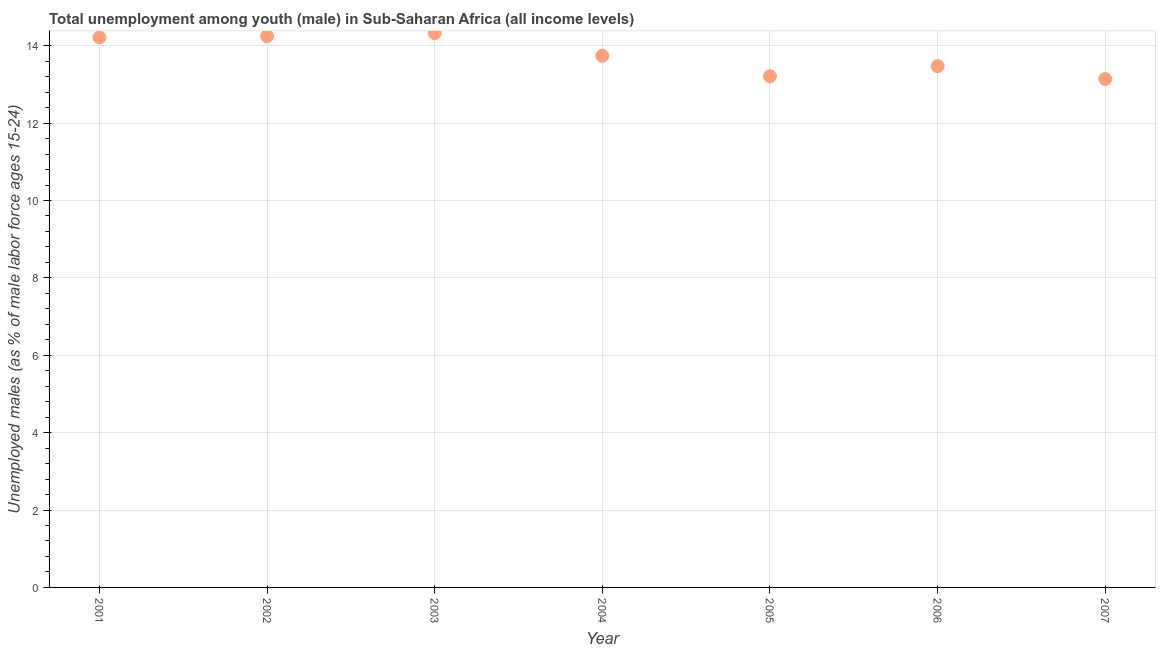What is the unemployed male youth population in 2003?
Your answer should be compact. 14.33. Across all years, what is the maximum unemployed male youth population?
Ensure brevity in your answer.  14.33. Across all years, what is the minimum unemployed male youth population?
Make the answer very short. 13.14. In which year was the unemployed male youth population maximum?
Offer a very short reply. 2003. What is the sum of the unemployed male youth population?
Make the answer very short. 96.35. What is the difference between the unemployed male youth population in 2003 and 2004?
Give a very brief answer. 0.59. What is the average unemployed male youth population per year?
Your answer should be compact. 13.76. What is the median unemployed male youth population?
Your answer should be very brief. 13.74. Do a majority of the years between 2005 and 2004 (inclusive) have unemployed male youth population greater than 1.2000000000000002 %?
Offer a terse response. No. What is the ratio of the unemployed male youth population in 2001 to that in 2007?
Your answer should be compact. 1.08. Is the unemployed male youth population in 2003 less than that in 2004?
Ensure brevity in your answer.  No. What is the difference between the highest and the second highest unemployed male youth population?
Offer a terse response. 0.08. What is the difference between the highest and the lowest unemployed male youth population?
Your response must be concise. 1.19. How many years are there in the graph?
Keep it short and to the point. 7. What is the difference between two consecutive major ticks on the Y-axis?
Your answer should be very brief. 2. Does the graph contain any zero values?
Make the answer very short. No. What is the title of the graph?
Give a very brief answer. Total unemployment among youth (male) in Sub-Saharan Africa (all income levels). What is the label or title of the Y-axis?
Your response must be concise. Unemployed males (as % of male labor force ages 15-24). What is the Unemployed males (as % of male labor force ages 15-24) in 2001?
Ensure brevity in your answer.  14.22. What is the Unemployed males (as % of male labor force ages 15-24) in 2002?
Offer a terse response. 14.25. What is the Unemployed males (as % of male labor force ages 15-24) in 2003?
Keep it short and to the point. 14.33. What is the Unemployed males (as % of male labor force ages 15-24) in 2004?
Your answer should be very brief. 13.74. What is the Unemployed males (as % of male labor force ages 15-24) in 2005?
Your answer should be very brief. 13.21. What is the Unemployed males (as % of male labor force ages 15-24) in 2006?
Provide a succinct answer. 13.47. What is the Unemployed males (as % of male labor force ages 15-24) in 2007?
Your answer should be very brief. 13.14. What is the difference between the Unemployed males (as % of male labor force ages 15-24) in 2001 and 2002?
Give a very brief answer. -0.03. What is the difference between the Unemployed males (as % of male labor force ages 15-24) in 2001 and 2003?
Your answer should be very brief. -0.11. What is the difference between the Unemployed males (as % of male labor force ages 15-24) in 2001 and 2004?
Your answer should be compact. 0.48. What is the difference between the Unemployed males (as % of male labor force ages 15-24) in 2001 and 2005?
Give a very brief answer. 1.01. What is the difference between the Unemployed males (as % of male labor force ages 15-24) in 2001 and 2006?
Provide a succinct answer. 0.74. What is the difference between the Unemployed males (as % of male labor force ages 15-24) in 2001 and 2007?
Your response must be concise. 1.08. What is the difference between the Unemployed males (as % of male labor force ages 15-24) in 2002 and 2003?
Your answer should be very brief. -0.08. What is the difference between the Unemployed males (as % of male labor force ages 15-24) in 2002 and 2004?
Your answer should be compact. 0.5. What is the difference between the Unemployed males (as % of male labor force ages 15-24) in 2002 and 2005?
Offer a terse response. 1.04. What is the difference between the Unemployed males (as % of male labor force ages 15-24) in 2002 and 2006?
Keep it short and to the point. 0.77. What is the difference between the Unemployed males (as % of male labor force ages 15-24) in 2002 and 2007?
Your answer should be compact. 1.11. What is the difference between the Unemployed males (as % of male labor force ages 15-24) in 2003 and 2004?
Your answer should be compact. 0.59. What is the difference between the Unemployed males (as % of male labor force ages 15-24) in 2003 and 2005?
Ensure brevity in your answer.  1.12. What is the difference between the Unemployed males (as % of male labor force ages 15-24) in 2003 and 2006?
Your response must be concise. 0.85. What is the difference between the Unemployed males (as % of male labor force ages 15-24) in 2003 and 2007?
Offer a terse response. 1.19. What is the difference between the Unemployed males (as % of male labor force ages 15-24) in 2004 and 2005?
Your answer should be compact. 0.53. What is the difference between the Unemployed males (as % of male labor force ages 15-24) in 2004 and 2006?
Give a very brief answer. 0.27. What is the difference between the Unemployed males (as % of male labor force ages 15-24) in 2004 and 2007?
Provide a short and direct response. 0.6. What is the difference between the Unemployed males (as % of male labor force ages 15-24) in 2005 and 2006?
Keep it short and to the point. -0.26. What is the difference between the Unemployed males (as % of male labor force ages 15-24) in 2005 and 2007?
Keep it short and to the point. 0.07. What is the difference between the Unemployed males (as % of male labor force ages 15-24) in 2006 and 2007?
Provide a succinct answer. 0.33. What is the ratio of the Unemployed males (as % of male labor force ages 15-24) in 2001 to that in 2002?
Give a very brief answer. 1. What is the ratio of the Unemployed males (as % of male labor force ages 15-24) in 2001 to that in 2004?
Provide a succinct answer. 1.03. What is the ratio of the Unemployed males (as % of male labor force ages 15-24) in 2001 to that in 2005?
Provide a succinct answer. 1.08. What is the ratio of the Unemployed males (as % of male labor force ages 15-24) in 2001 to that in 2006?
Offer a terse response. 1.05. What is the ratio of the Unemployed males (as % of male labor force ages 15-24) in 2001 to that in 2007?
Give a very brief answer. 1.08. What is the ratio of the Unemployed males (as % of male labor force ages 15-24) in 2002 to that in 2005?
Provide a short and direct response. 1.08. What is the ratio of the Unemployed males (as % of male labor force ages 15-24) in 2002 to that in 2006?
Offer a very short reply. 1.06. What is the ratio of the Unemployed males (as % of male labor force ages 15-24) in 2002 to that in 2007?
Offer a terse response. 1.08. What is the ratio of the Unemployed males (as % of male labor force ages 15-24) in 2003 to that in 2004?
Ensure brevity in your answer.  1.04. What is the ratio of the Unemployed males (as % of male labor force ages 15-24) in 2003 to that in 2005?
Offer a terse response. 1.08. What is the ratio of the Unemployed males (as % of male labor force ages 15-24) in 2003 to that in 2006?
Your response must be concise. 1.06. What is the ratio of the Unemployed males (as % of male labor force ages 15-24) in 2003 to that in 2007?
Make the answer very short. 1.09. What is the ratio of the Unemployed males (as % of male labor force ages 15-24) in 2004 to that in 2006?
Offer a terse response. 1.02. What is the ratio of the Unemployed males (as % of male labor force ages 15-24) in 2004 to that in 2007?
Offer a terse response. 1.05. What is the ratio of the Unemployed males (as % of male labor force ages 15-24) in 2005 to that in 2007?
Your answer should be compact. 1. What is the ratio of the Unemployed males (as % of male labor force ages 15-24) in 2006 to that in 2007?
Offer a terse response. 1.02. 